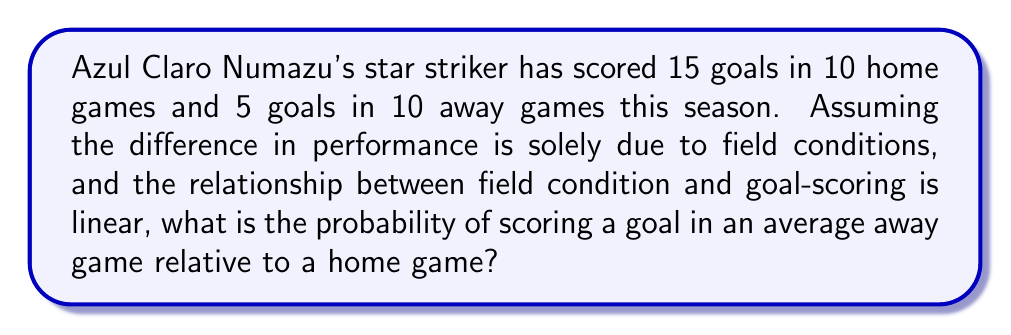Could you help me with this problem? Let's approach this step-by-step:

1) First, we need to calculate the average goals per game for both home and away matches:

   Home: $\frac{15 \text{ goals}}{10 \text{ games}} = 1.5 \text{ goals/game}$
   Away: $\frac{5 \text{ goals}}{10 \text{ games}} = 0.5 \text{ goals/game}$

2) We assume that the difference in performance is solely due to field conditions and that the relationship is linear. This means we can set up a simple proportion:

   $\frac{\text{Away performance}}{\text{Home performance}} = \frac{0.5}{1.5}$

3) To simplify this fraction:

   $\frac{0.5}{1.5} = \frac{1}{3}$

4) This ratio represents the relative probability of scoring a goal in an away game compared to a home game.

5) To express this as a probability, we can convert the fraction to a decimal:

   $\frac{1}{3} \approx 0.3333...$

6) This can be expressed as 33.33% or approximately 1/3.

Therefore, the probability of scoring a goal in an average away game is about 1/3 or 33.33% relative to a home game.
Answer: $\frac{1}{3}$ or 0.3333 